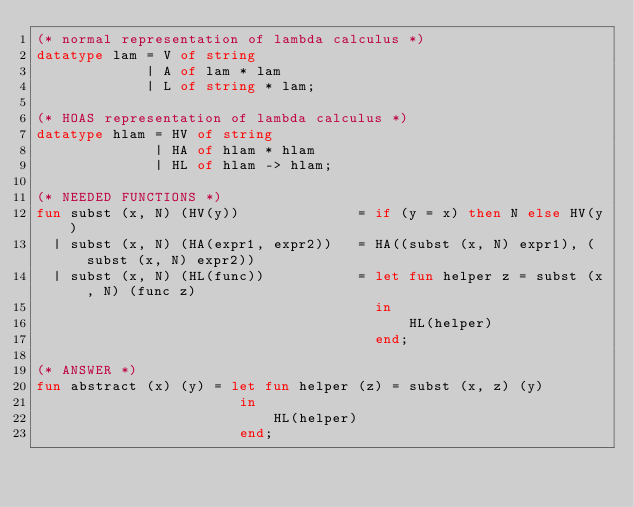Convert code to text. <code><loc_0><loc_0><loc_500><loc_500><_SML_>(* normal representation of lambda calculus *)
datatype lam = V of string
             | A of lam * lam
             | L of string * lam;

(* HOAS representation of lambda calculus *)
datatype hlam = HV of string
              | HA of hlam * hlam
              | HL of hlam -> hlam;

(* NEEDED FUNCTIONS *)
fun subst (x, N) (HV(y))              = if (y = x) then N else HV(y)
  | subst (x, N) (HA(expr1, expr2))   = HA((subst (x, N) expr1), (subst (x, N) expr2))
  | subst (x, N) (HL(func))           = let fun helper z = subst (x, N) (func z)
                                        in
                                            HL(helper)
                                        end;

(* ANSWER *)
fun abstract (x) (y) = let fun helper (z) = subst (x, z) (y)
                        in
                            HL(helper)
                        end;
</code> 